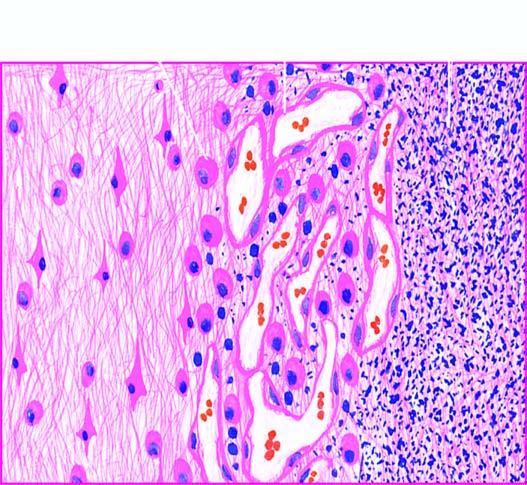does the surrounding zone show granulation tissue and gliosis?
Answer the question using a single word or phrase. Yes 